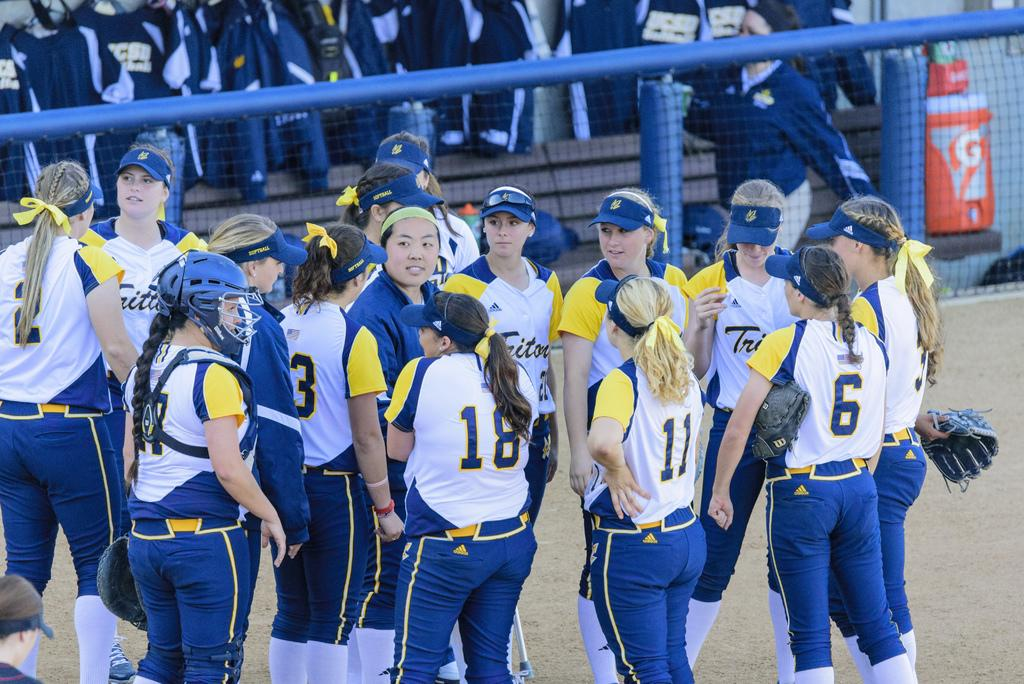<image>
Provide a brief description of the given image. a sport team gathers together wearing numbers like 18 and 11 